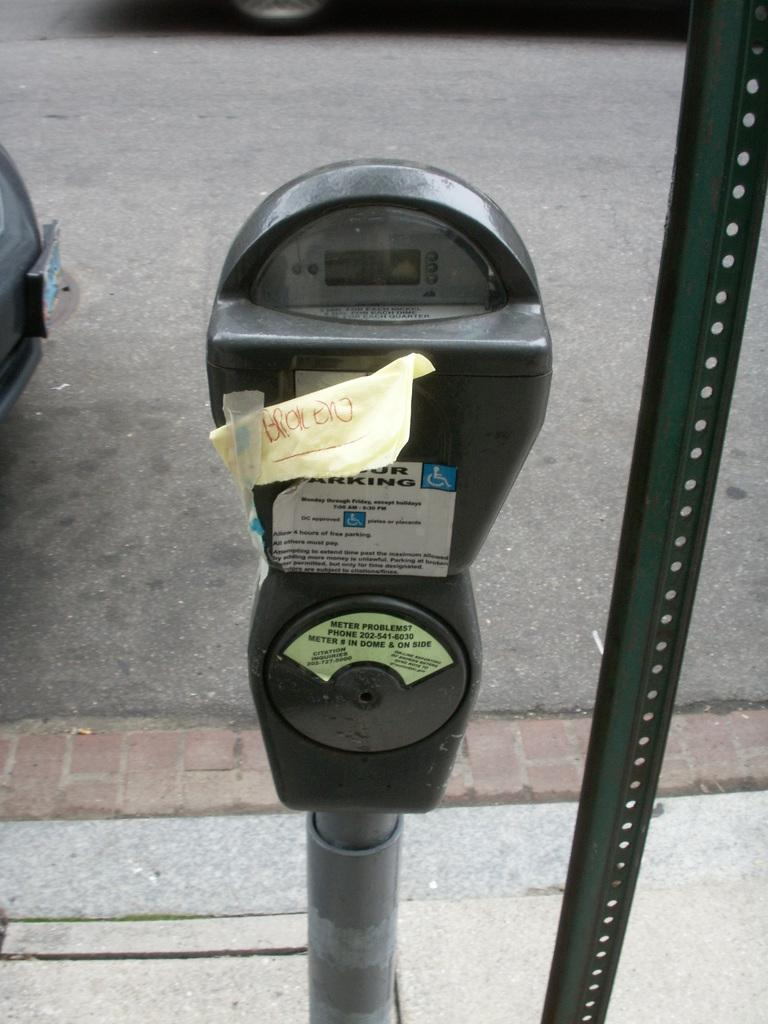<image>
Relay a brief, clear account of the picture shown. A parking meter with a note taped on the coin slot that says broken. 